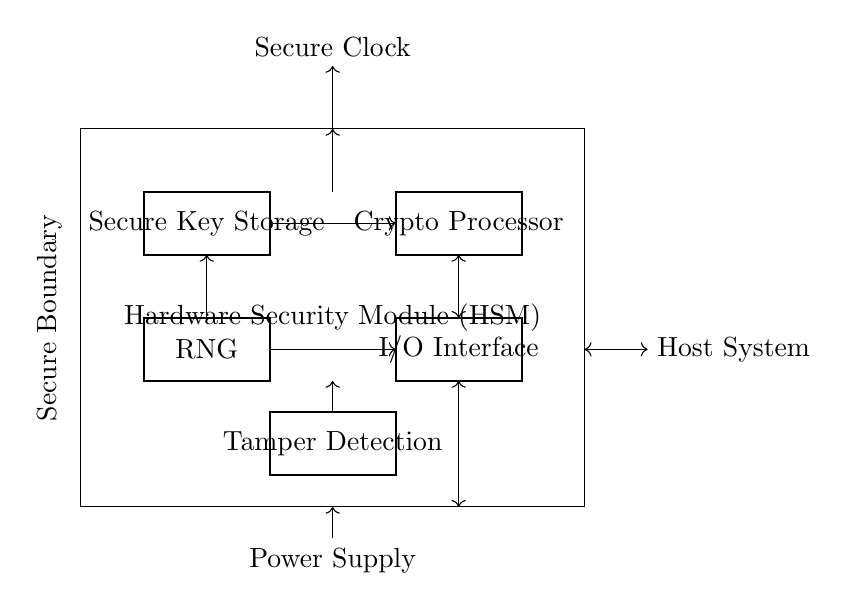What is the main function of the Hardware Security Module? The main function of the Hardware Security Module is to perform secure key storage and cryptographic operations. This is indicated by the label on the main block in the circuit.
Answer: secure key storage and cryptographic operations How many components are shown in the HSM circuit? There are five distinct components shown in the HSM circuit: Secure Key Storage, Crypto Processor, Random Number Generator, I/O Interface, and Tamper Detection. Counting each rectangle in the diagram confirms this.
Answer: five What type of component is the RNG? The RNG is classified as a Random Number Generator, as indicated by the label on that specific rectangle in the circuit diagram.
Answer: Random Number Generator Which component connects to the Secure Clock? The component that connects to the Secure Clock is the main Hardware Security Module. This connection is indicated by the upwards arrow leading from the top of the HSM block.
Answer: Hardware Security Module What is the purpose of the Tamper Detection feature? The Tamper Detection feature is designed to identify unauthorized access or manipulation of the hardware, ensuring the security of the keys stored. This is inferred from its name and placement in the circuit.
Answer: unauthorized access identification How do the Secure Key Storage and Crypto Processor interact? The Secure Key Storage interacts with the Crypto Processor through a directed connection represented by an arrow, indicating that data or keys flow from the Secure Key Storage to the Crypto Processor for cryptographic operations.
Answer: data flow direction 